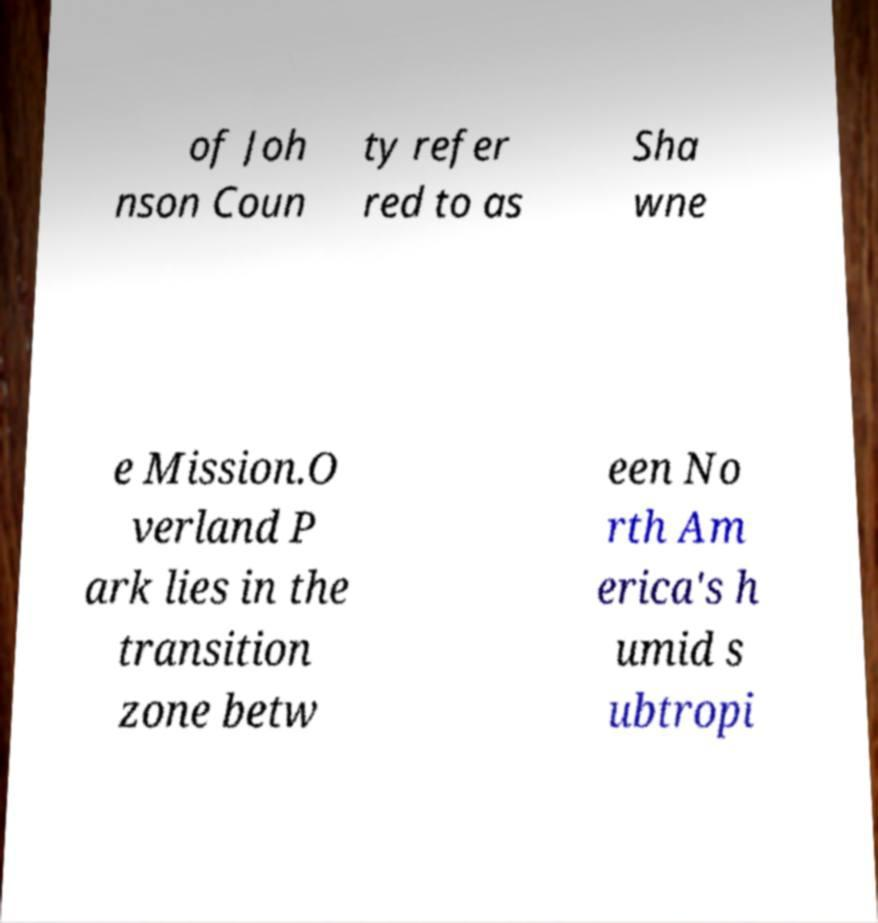Can you accurately transcribe the text from the provided image for me? of Joh nson Coun ty refer red to as Sha wne e Mission.O verland P ark lies in the transition zone betw een No rth Am erica's h umid s ubtropi 